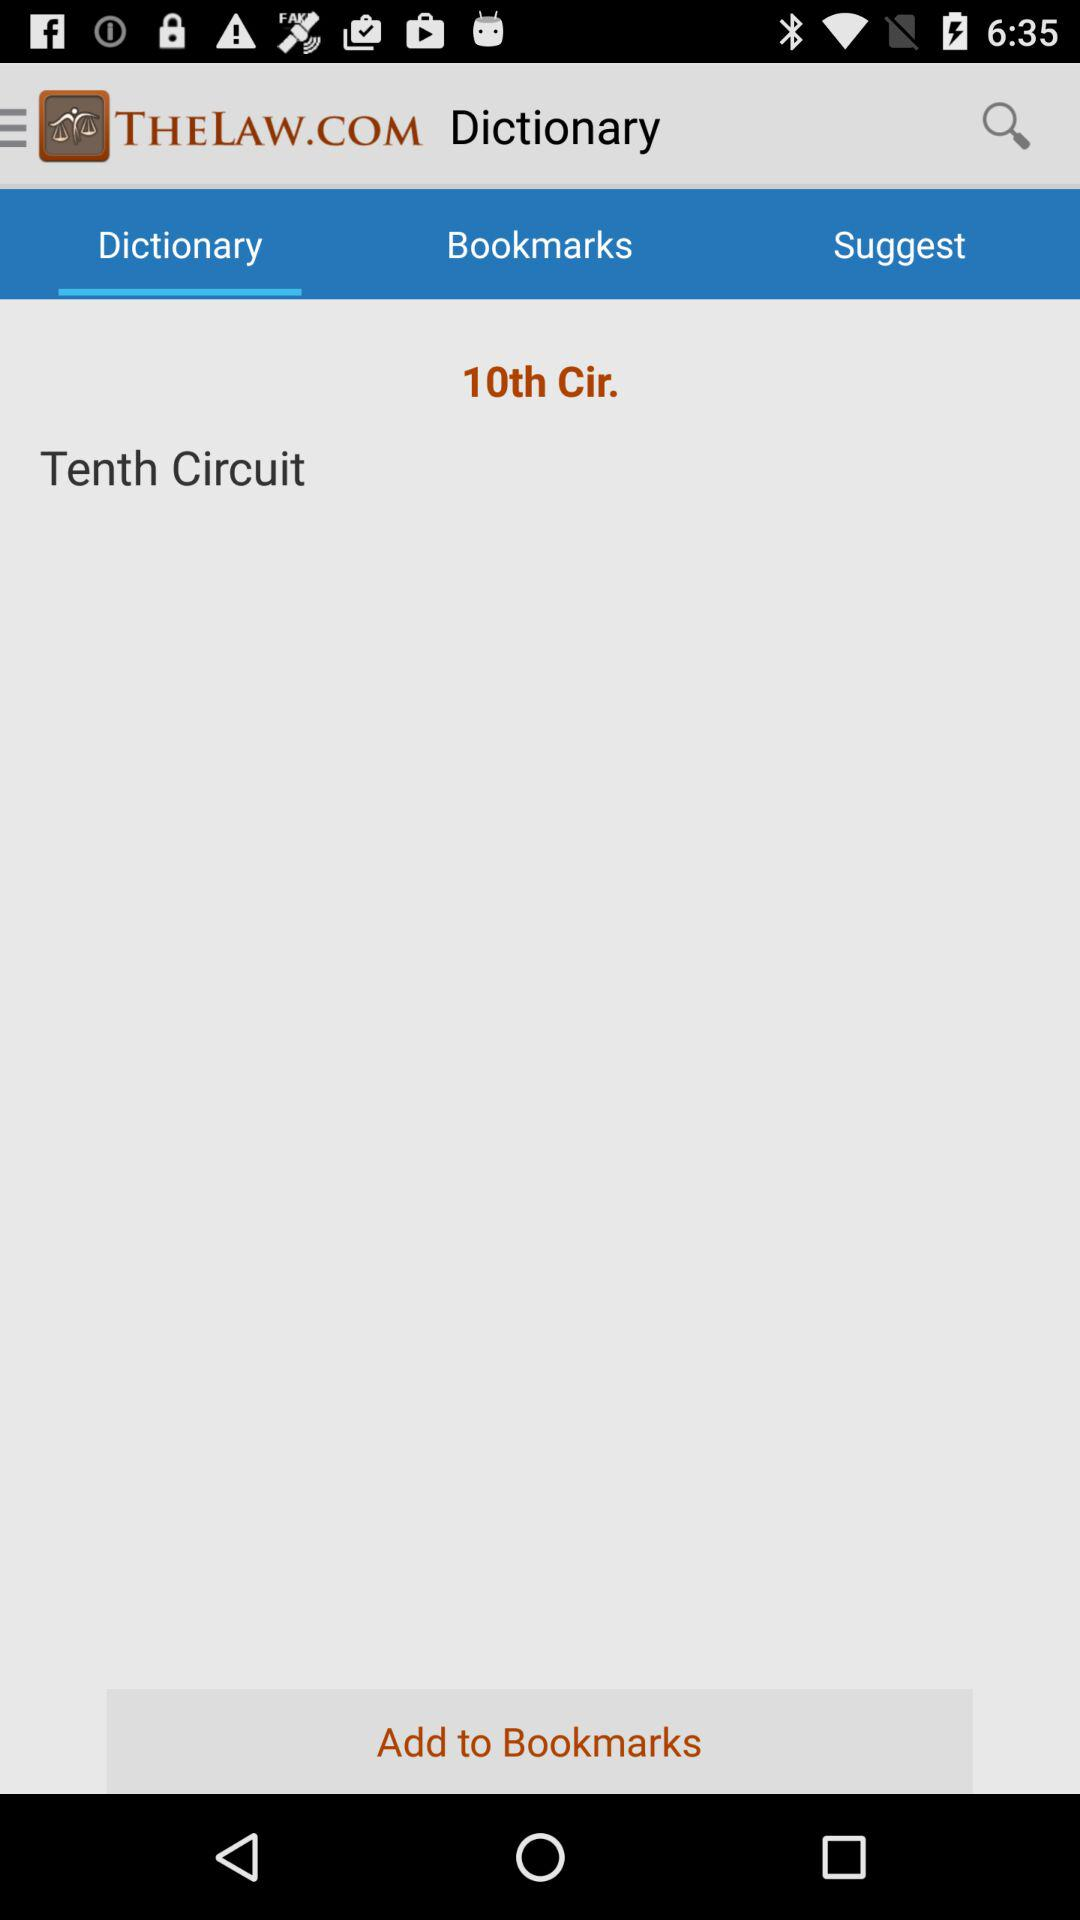Which word is written in the "Dictionary" option? The word written in the "Dictionary" option is Tenth Circuit. 